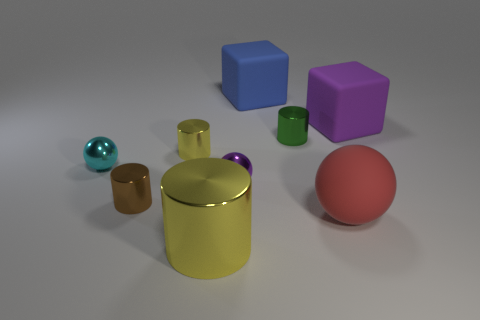There is a purple thing that is in front of the purple cube; what is its shape?
Provide a short and direct response. Sphere. There is a sphere that is to the left of the metallic cylinder that is in front of the red object; what is it made of?
Give a very brief answer. Metal. Are there more large purple blocks that are in front of the brown metallic thing than small purple metal balls?
Your answer should be very brief. No. What number of other things are the same color as the large matte sphere?
Your response must be concise. 0. There is a yellow metallic object that is the same size as the blue rubber block; what is its shape?
Give a very brief answer. Cylinder. There is a large block in front of the rubber block behind the big purple cube; what number of objects are left of it?
Give a very brief answer. 8. How many rubber objects are big purple spheres or blue things?
Provide a short and direct response. 1. What is the color of the object that is both on the right side of the small green thing and in front of the big purple matte object?
Offer a terse response. Red. There is a cube in front of the blue matte object; is its size the same as the red thing?
Give a very brief answer. Yes. What number of objects are either big cubes to the right of the blue matte cube or blue cubes?
Provide a succinct answer. 2. 